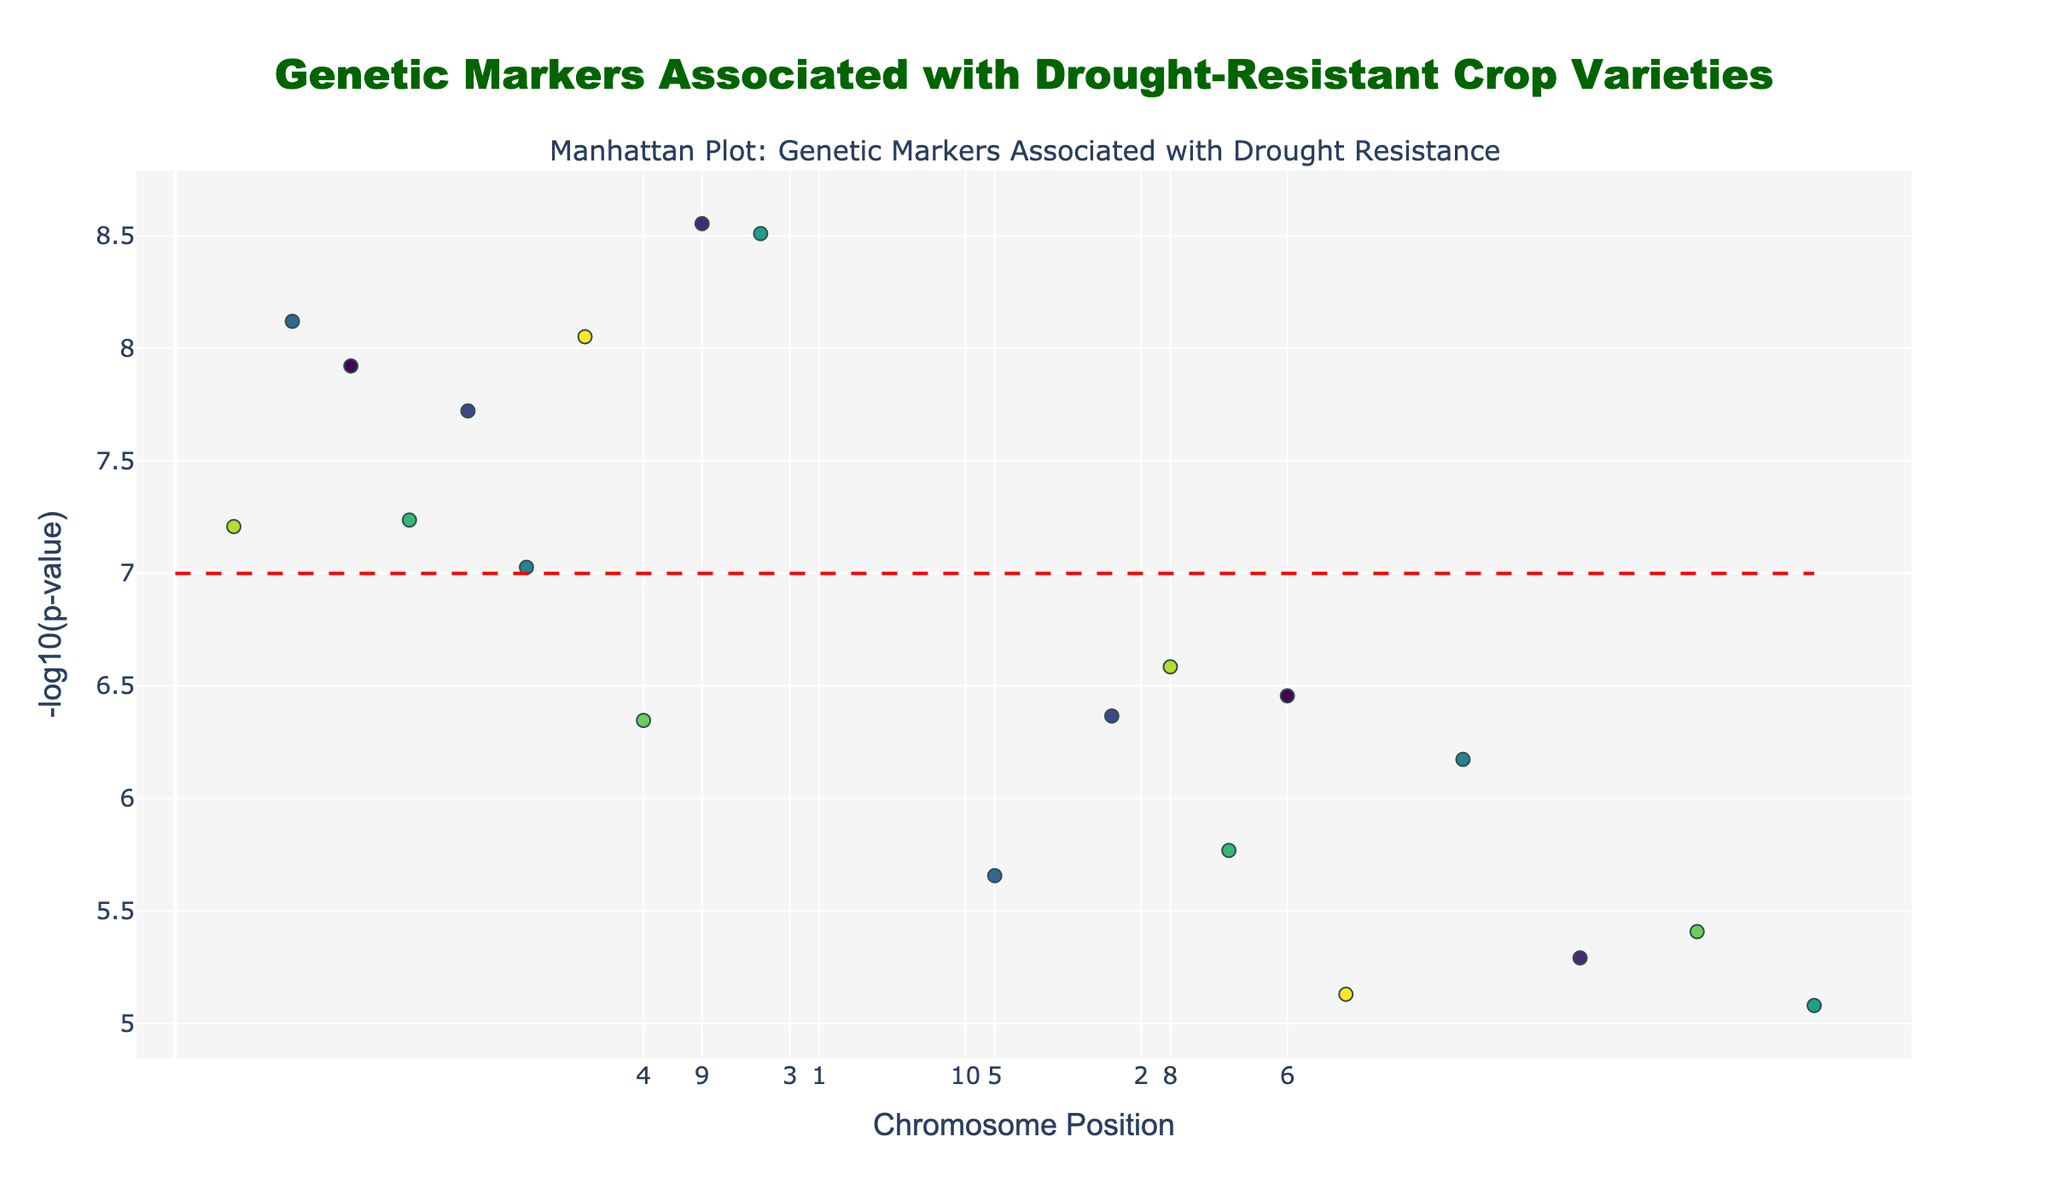What is the title of the plot? The title of the plot is usually located at the top of the figure. In this case, it is centered and in bold font.
Answer: Genetic Markers Associated with Drought-Resistant Crop Varieties What does the y-axis represent? The y-axis is typically labeled to indicate what the values represent. Here, the y-axis is labeled as "-log10(p-value)".
Answer: -log10(p-value) Which gene has the smallest p-value? To determine this, we look for the highest value on the y-axis because higher -log10(p-value) corresponds to smaller p-values. The gene with the highest point is NCED3 on Chromosome 2.
Answer: NCED3 Which chromosome has the most significant genetic markers above the threshold line? By counting the number of points above the threshold line (y=7) for each chromosome, Chromosome 6 has the most significant genetic markers above the threshold line with two markers (DREB1A and MYB60).
Answer: Chromosome 6 What is the significance threshold set in the plot? The threshold line is often a horizontal line drawn across the plot. In this case, it is a red dashed line at -log10(p-value) = 7.
Answer: 7 How many genes have -log10(p-value) greater than 8? To find this, we count the number of points above the y=8 line. There are three such points.
Answer: 3 Which genes are associated with Chromosome 4 and what traits are they linked to? Reviewing the positions and genes on Chromosome 4, we find CBF3 (Cold and drought tolerance) and P5CS (Proline accumulation).
Answer: CBF3 (Cold and drought tolerance), P5CS (Proline accumulation) What is the -log10(p-value) of the gene associated with potassium uptake? The gene associated with potassium uptake is CIPK23, which has its p-value converted to -log10(p-value). CIPK23 is plotted with approximately -log10(7.4e-6) = 5.13.
Answer: 5.13 Which Chromosome has a marker associated with osmotic adjustment? The trait 'Osmotic adjustment' is associated with the gene ERD1, which is located on Chromosome 1.
Answer: Chromosome 1 Compare the significance of the markers associated with 'ABA biosynthesis' and 'Salt and drought tolerance'. Which one is more significant? The significance is evaluated by -log10(p-value). ABA biosynthesis (NCED3) has -log10(2.8e-9) = 8.55, and Salt and drought tolerance (SOS1) has -log10(1.7e-6) = 5.77. ABA biosynthesis is more significant.
Answer: ABA biosynthesis 